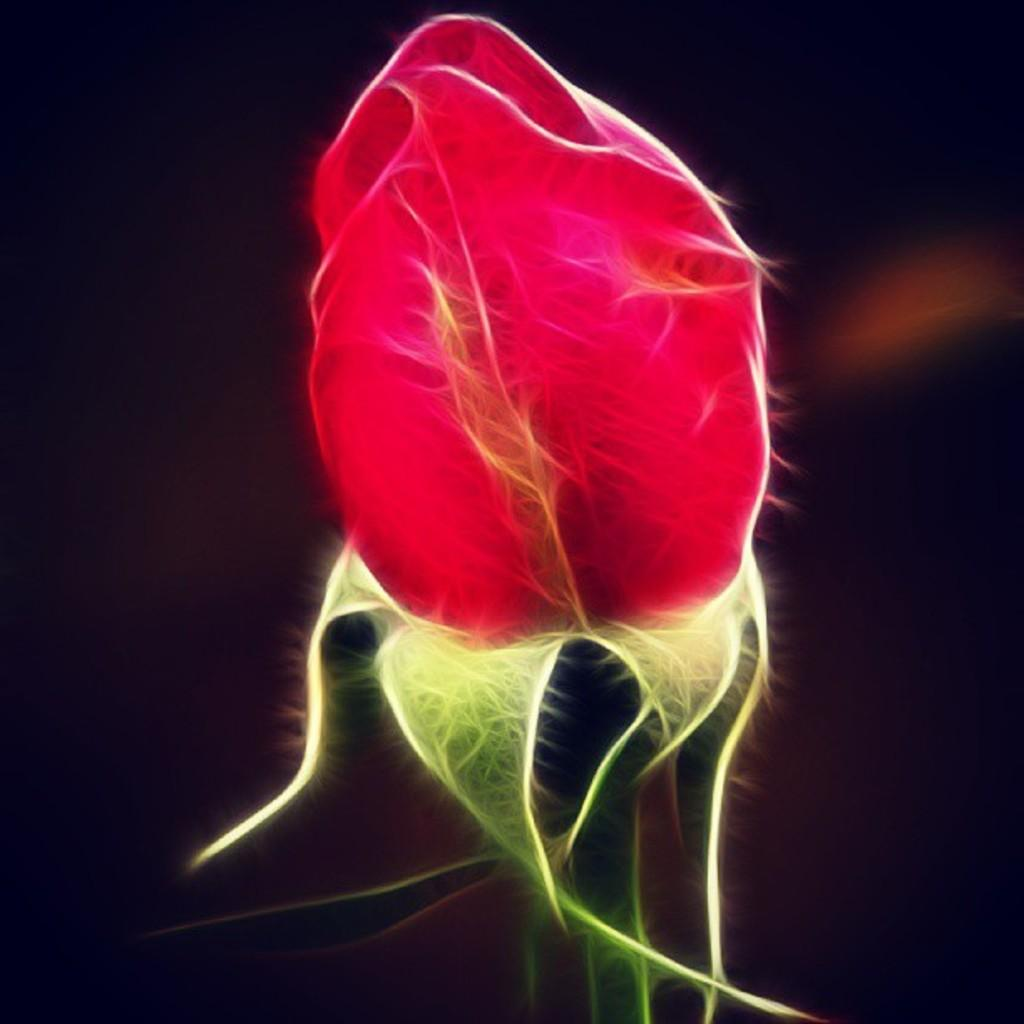What type of image is being described? The image is graphical in nature. What is the main subject of the image? There is a rose flower in the front of the image. How would you describe the background of the image? The background of the image is dark. What type of table is visible in the image? There is no table present in the image; it features a rose flower in the foreground and a dark background. 